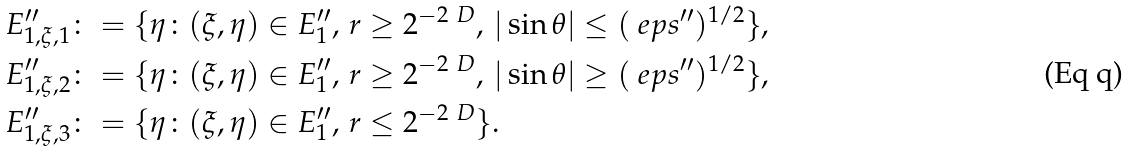Convert formula to latex. <formula><loc_0><loc_0><loc_500><loc_500>E ^ { \prime \prime } _ { 1 , \xi , 1 } \colon & = \{ \eta \colon ( \xi , \eta ) \in E ^ { \prime \prime } _ { 1 } , \, r \geq 2 ^ { - 2 \ D } , \, | \sin \theta | \leq ( \ e p s ^ { \prime \prime } ) ^ { 1 / 2 } \} , \\ E ^ { \prime \prime } _ { 1 , \xi , 2 } \colon & = \{ \eta \colon ( \xi , \eta ) \in E ^ { \prime \prime } _ { 1 } , \, r \geq 2 ^ { - 2 \ D } , \, | \sin \theta | \geq ( \ e p s ^ { \prime \prime } ) ^ { 1 / 2 } \} , \\ E ^ { \prime \prime } _ { 1 , \xi , 3 } \colon & = \{ \eta \colon ( \xi , \eta ) \in E ^ { \prime \prime } _ { 1 } , \, r \leq 2 ^ { - 2 \ D } \} .</formula> 